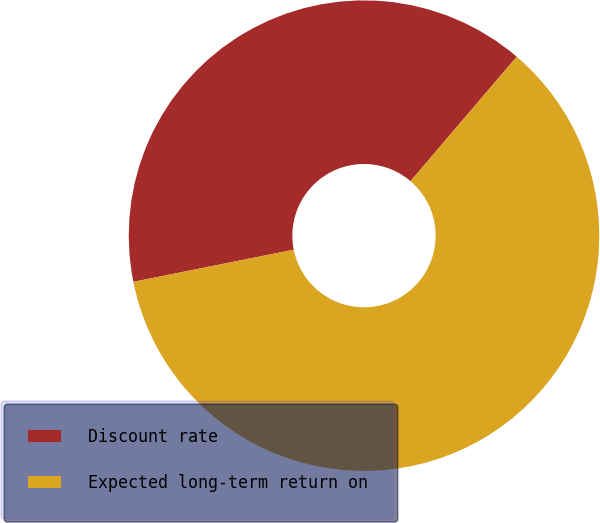Convert chart. <chart><loc_0><loc_0><loc_500><loc_500><pie_chart><fcel>Discount rate<fcel>Expected long-term return on<nl><fcel>39.39%<fcel>60.61%<nl></chart> 